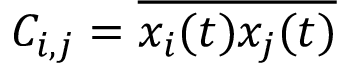Convert formula to latex. <formula><loc_0><loc_0><loc_500><loc_500>C _ { i , j } = \overline { { x _ { i } ( t ) x _ { j } ( t ) } }</formula> 